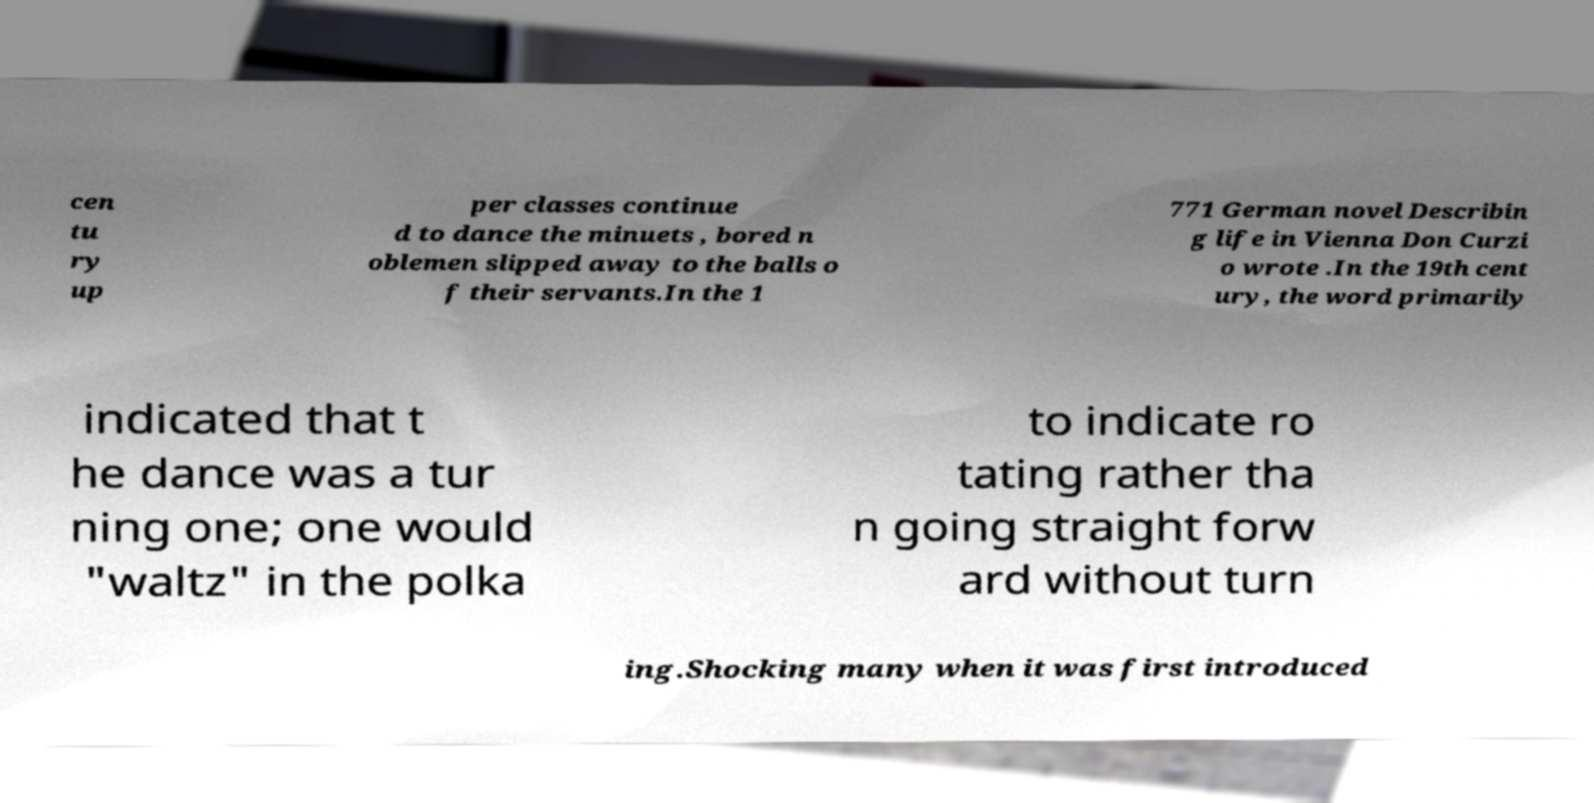Please read and relay the text visible in this image. What does it say? cen tu ry up per classes continue d to dance the minuets , bored n oblemen slipped away to the balls o f their servants.In the 1 771 German novel Describin g life in Vienna Don Curzi o wrote .In the 19th cent ury, the word primarily indicated that t he dance was a tur ning one; one would "waltz" in the polka to indicate ro tating rather tha n going straight forw ard without turn ing.Shocking many when it was first introduced 